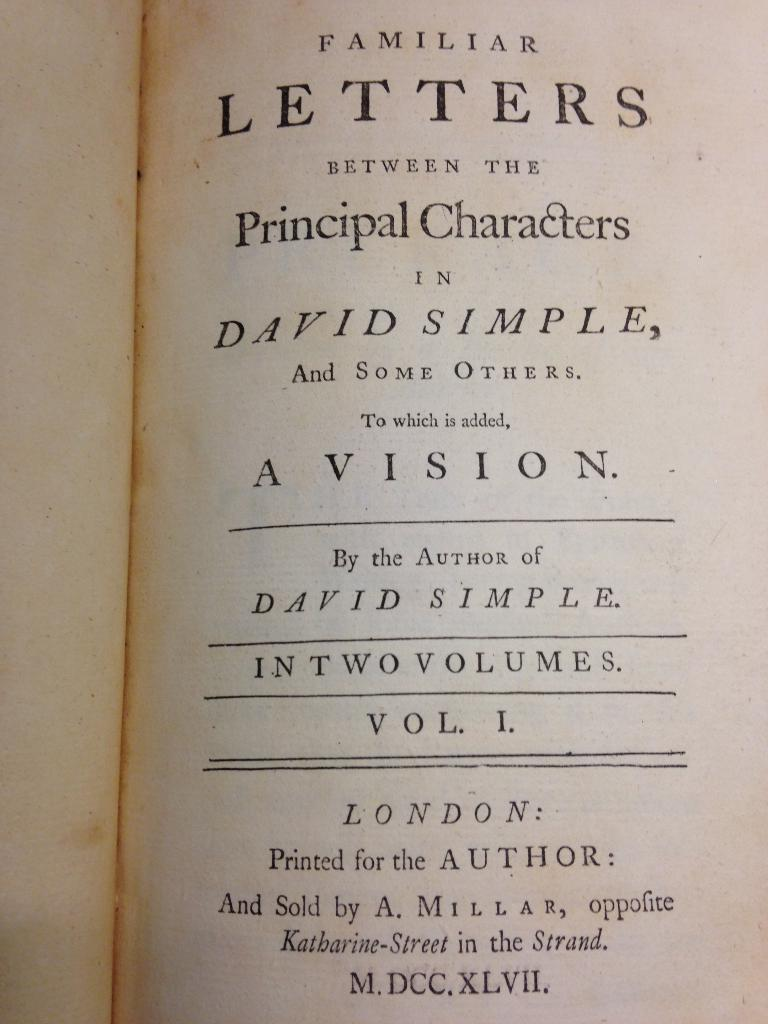Provide a one-sentence caption for the provided image. A title page to Familiar Letters between the Principal Characters in David Simple, volume 1. 